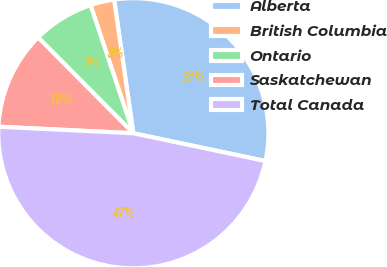<chart> <loc_0><loc_0><loc_500><loc_500><pie_chart><fcel>Alberta<fcel>British Columbia<fcel>Ontario<fcel>Saskatchewan<fcel>Total Canada<nl><fcel>30.57%<fcel>2.86%<fcel>7.32%<fcel>11.78%<fcel>47.47%<nl></chart> 